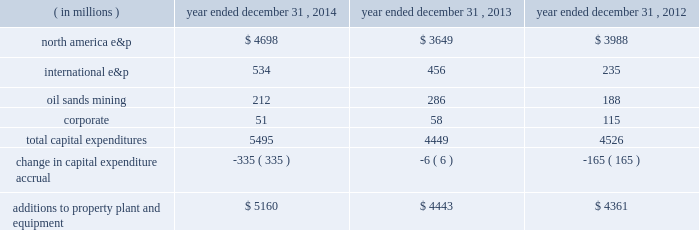Additions to property , plant and equipment are our most significant use of cash and cash equivalents .
The table shows capital expenditures related to continuing operations by segment and reconciles to additions to property , plant and equipment as presented in the consolidated statements of cash flows for 2014 , 2013 and 2012: .
As of december 31 , 2014 , we had repurchased a total of 121 million common shares at a cost of $ 4.7 billion , including 29 million shares at a cost of $ 1 billion in the first six months of 2014 and 14 million shares at a cost of $ 500 million in the third quarter of 2013 .
See item 8 .
Financial statements and supplementary data 2013 note 22 to the consolidated financial statements for discussion of purchases of common stock .
Liquidity and capital resources our main sources of liquidity are cash and cash equivalents , internally generated cash flow from operations , continued access to capital markets , our committed revolving credit facility and sales of non-strategic assets .
Our working capital requirements are supported by these sources and we may issue commercial paper backed by our $ 2.5 billion revolving credit facility to meet short-term cash requirements .
Because of the alternatives available to us as discussed above and access to capital markets through the shelf registration discussed below , we believe that our short-term and long-term liquidity is adequate to fund not only our current operations , but also our near-term and long-term funding requirements including our capital spending programs , dividend payments , defined benefit plan contributions , repayment of debt maturities and other amounts that may ultimately be paid in connection with contingencies .
At december 31 , 2014 , we had approximately $ 4.9 billion of liquidity consisting of $ 2.4 billion in cash and cash equivalents and $ 2.5 billion availability under our revolving credit facility .
As discussed in more detail below in 201coutlook 201d , we are targeting a $ 3.5 billion budget for 2015 .
Based on our projected 2015 cash outlays for our capital program and dividends , we expect to outspend our cash flows from operations for the year .
We will be constantly monitoring our available liquidity during 2015 and we have the flexibility to adjust our budget throughout the year in response to the commodity price environment .
We will also continue to drive the fundamentals of expense management , including organizational capacity and operational reliability .
Capital resources credit arrangements and borrowings in may 2014 , we amended our $ 2.5 billion unsecured revolving credit facility and extended the maturity to may 2019 .
See note 16 to the consolidated financial statements for additional terms and rates .
At december 31 , 2014 , we had no borrowings against our revolving credit facility and no amounts outstanding under our u.s .
Commercial paper program that is backed by the revolving credit facility .
At december 31 , 2014 , we had $ 6391 million in long-term debt outstanding , and $ 1068 million is due within one year , of which the majority is due in the fourth quarter of 2015 .
We do not have any triggers on any of our corporate debt that would cause an event of default in the case of a downgrade of our credit ratings .
Shelf registration we have a universal shelf registration statement filed with the sec , under which we , as "well-known seasoned issuer" for purposes of sec rules , have the ability to issue and sell an indeterminate amount of various types of debt and equity securities from time to time. .
What percentage of total capital expenditures were attributed to north america e&p in 2014? 
Computations: (4698 / 5495)
Answer: 0.85496. Additions to property , plant and equipment are our most significant use of cash and cash equivalents .
The table shows capital expenditures related to continuing operations by segment and reconciles to additions to property , plant and equipment as presented in the consolidated statements of cash flows for 2014 , 2013 and 2012: .
As of december 31 , 2014 , we had repurchased a total of 121 million common shares at a cost of $ 4.7 billion , including 29 million shares at a cost of $ 1 billion in the first six months of 2014 and 14 million shares at a cost of $ 500 million in the third quarter of 2013 .
See item 8 .
Financial statements and supplementary data 2013 note 22 to the consolidated financial statements for discussion of purchases of common stock .
Liquidity and capital resources our main sources of liquidity are cash and cash equivalents , internally generated cash flow from operations , continued access to capital markets , our committed revolving credit facility and sales of non-strategic assets .
Our working capital requirements are supported by these sources and we may issue commercial paper backed by our $ 2.5 billion revolving credit facility to meet short-term cash requirements .
Because of the alternatives available to us as discussed above and access to capital markets through the shelf registration discussed below , we believe that our short-term and long-term liquidity is adequate to fund not only our current operations , but also our near-term and long-term funding requirements including our capital spending programs , dividend payments , defined benefit plan contributions , repayment of debt maturities and other amounts that may ultimately be paid in connection with contingencies .
At december 31 , 2014 , we had approximately $ 4.9 billion of liquidity consisting of $ 2.4 billion in cash and cash equivalents and $ 2.5 billion availability under our revolving credit facility .
As discussed in more detail below in 201coutlook 201d , we are targeting a $ 3.5 billion budget for 2015 .
Based on our projected 2015 cash outlays for our capital program and dividends , we expect to outspend our cash flows from operations for the year .
We will be constantly monitoring our available liquidity during 2015 and we have the flexibility to adjust our budget throughout the year in response to the commodity price environment .
We will also continue to drive the fundamentals of expense management , including organizational capacity and operational reliability .
Capital resources credit arrangements and borrowings in may 2014 , we amended our $ 2.5 billion unsecured revolving credit facility and extended the maturity to may 2019 .
See note 16 to the consolidated financial statements for additional terms and rates .
At december 31 , 2014 , we had no borrowings against our revolving credit facility and no amounts outstanding under our u.s .
Commercial paper program that is backed by the revolving credit facility .
At december 31 , 2014 , we had $ 6391 million in long-term debt outstanding , and $ 1068 million is due within one year , of which the majority is due in the fourth quarter of 2015 .
We do not have any triggers on any of our corporate debt that would cause an event of default in the case of a downgrade of our credit ratings .
Shelf registration we have a universal shelf registration statement filed with the sec , under which we , as "well-known seasoned issuer" for purposes of sec rules , have the ability to issue and sell an indeterminate amount of various types of debt and equity securities from time to time. .
What was the average three year cash flow , in millions , from oil sands mining? 
Computations: table_average(oil sands mining, none)
Answer: 228.66667. 